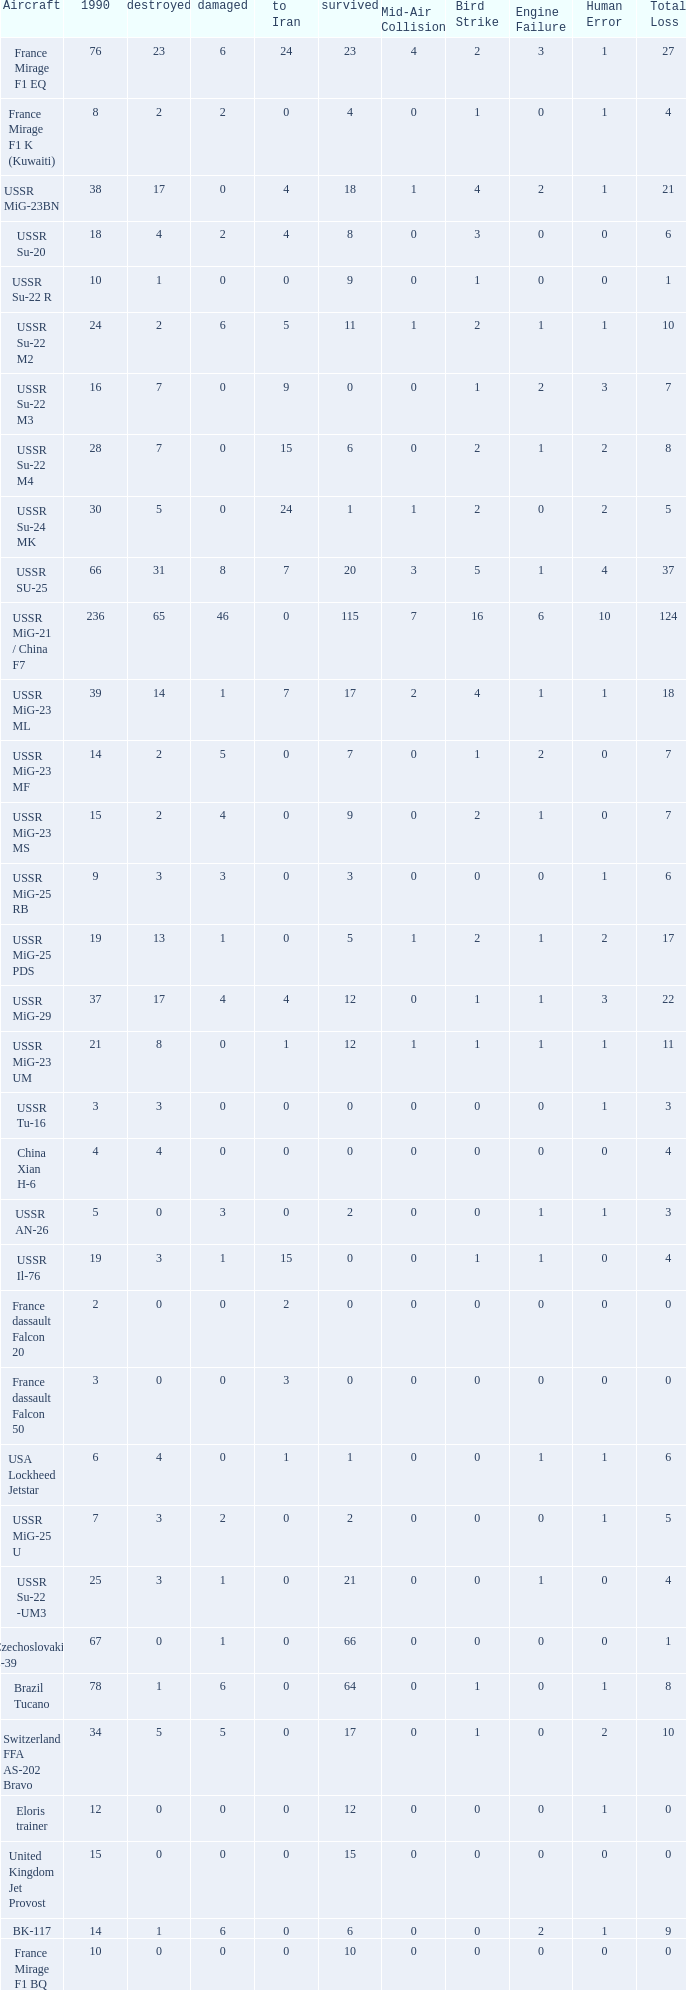If the aircraft was  ussr mig-25 rb how many were destroyed? 3.0. 